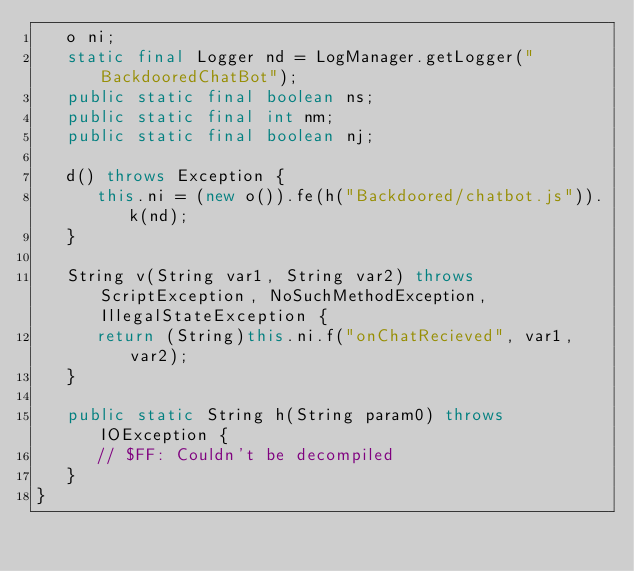Convert code to text. <code><loc_0><loc_0><loc_500><loc_500><_Java_>   o ni;
   static final Logger nd = LogManager.getLogger("BackdooredChatBot");
   public static final boolean ns;
   public static final int nm;
   public static final boolean nj;

   d() throws Exception {
      this.ni = (new o()).fe(h("Backdoored/chatbot.js")).k(nd);
   }

   String v(String var1, String var2) throws ScriptException, NoSuchMethodException, IllegalStateException {
      return (String)this.ni.f("onChatRecieved", var1, var2);
   }

   public static String h(String param0) throws IOException {
      // $FF: Couldn't be decompiled
   }
}
</code> 